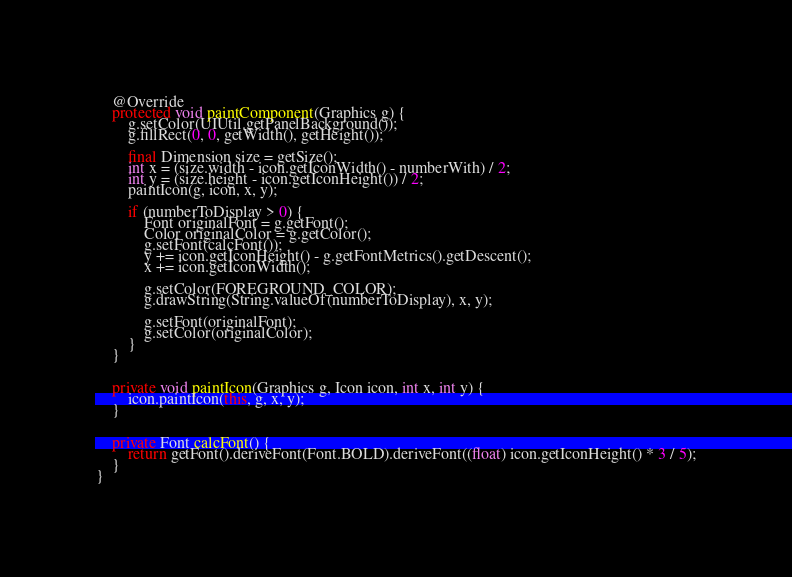<code> <loc_0><loc_0><loc_500><loc_500><_Java_>
    @Override
    protected void paintComponent(Graphics g) {
        g.setColor(UIUtil.getPanelBackground());
        g.fillRect(0, 0, getWidth(), getHeight());

        final Dimension size = getSize();
        int x = (size.width - icon.getIconWidth() - numberWith) / 2;
        int y = (size.height - icon.getIconHeight()) / 2;
        paintIcon(g, icon, x, y);

        if (numberToDisplay > 0) {
            Font originalFont = g.getFont();
            Color originalColor = g.getColor();
            g.setFont(calcFont());
            y += icon.getIconHeight() - g.getFontMetrics().getDescent();
            x += icon.getIconWidth();

            g.setColor(FOREGROUND_COLOR);
            g.drawString(String.valueOf(numberToDisplay), x, y);

            g.setFont(originalFont);
            g.setColor(originalColor);
        }
    }


    private void paintIcon(Graphics g, Icon icon, int x, int y) {
        icon.paintIcon(this, g, x, y);
    }


    private Font calcFont() {
        return getFont().deriveFont(Font.BOLD).deriveFont((float) icon.getIconHeight() * 3 / 5);
    }
}
</code> 